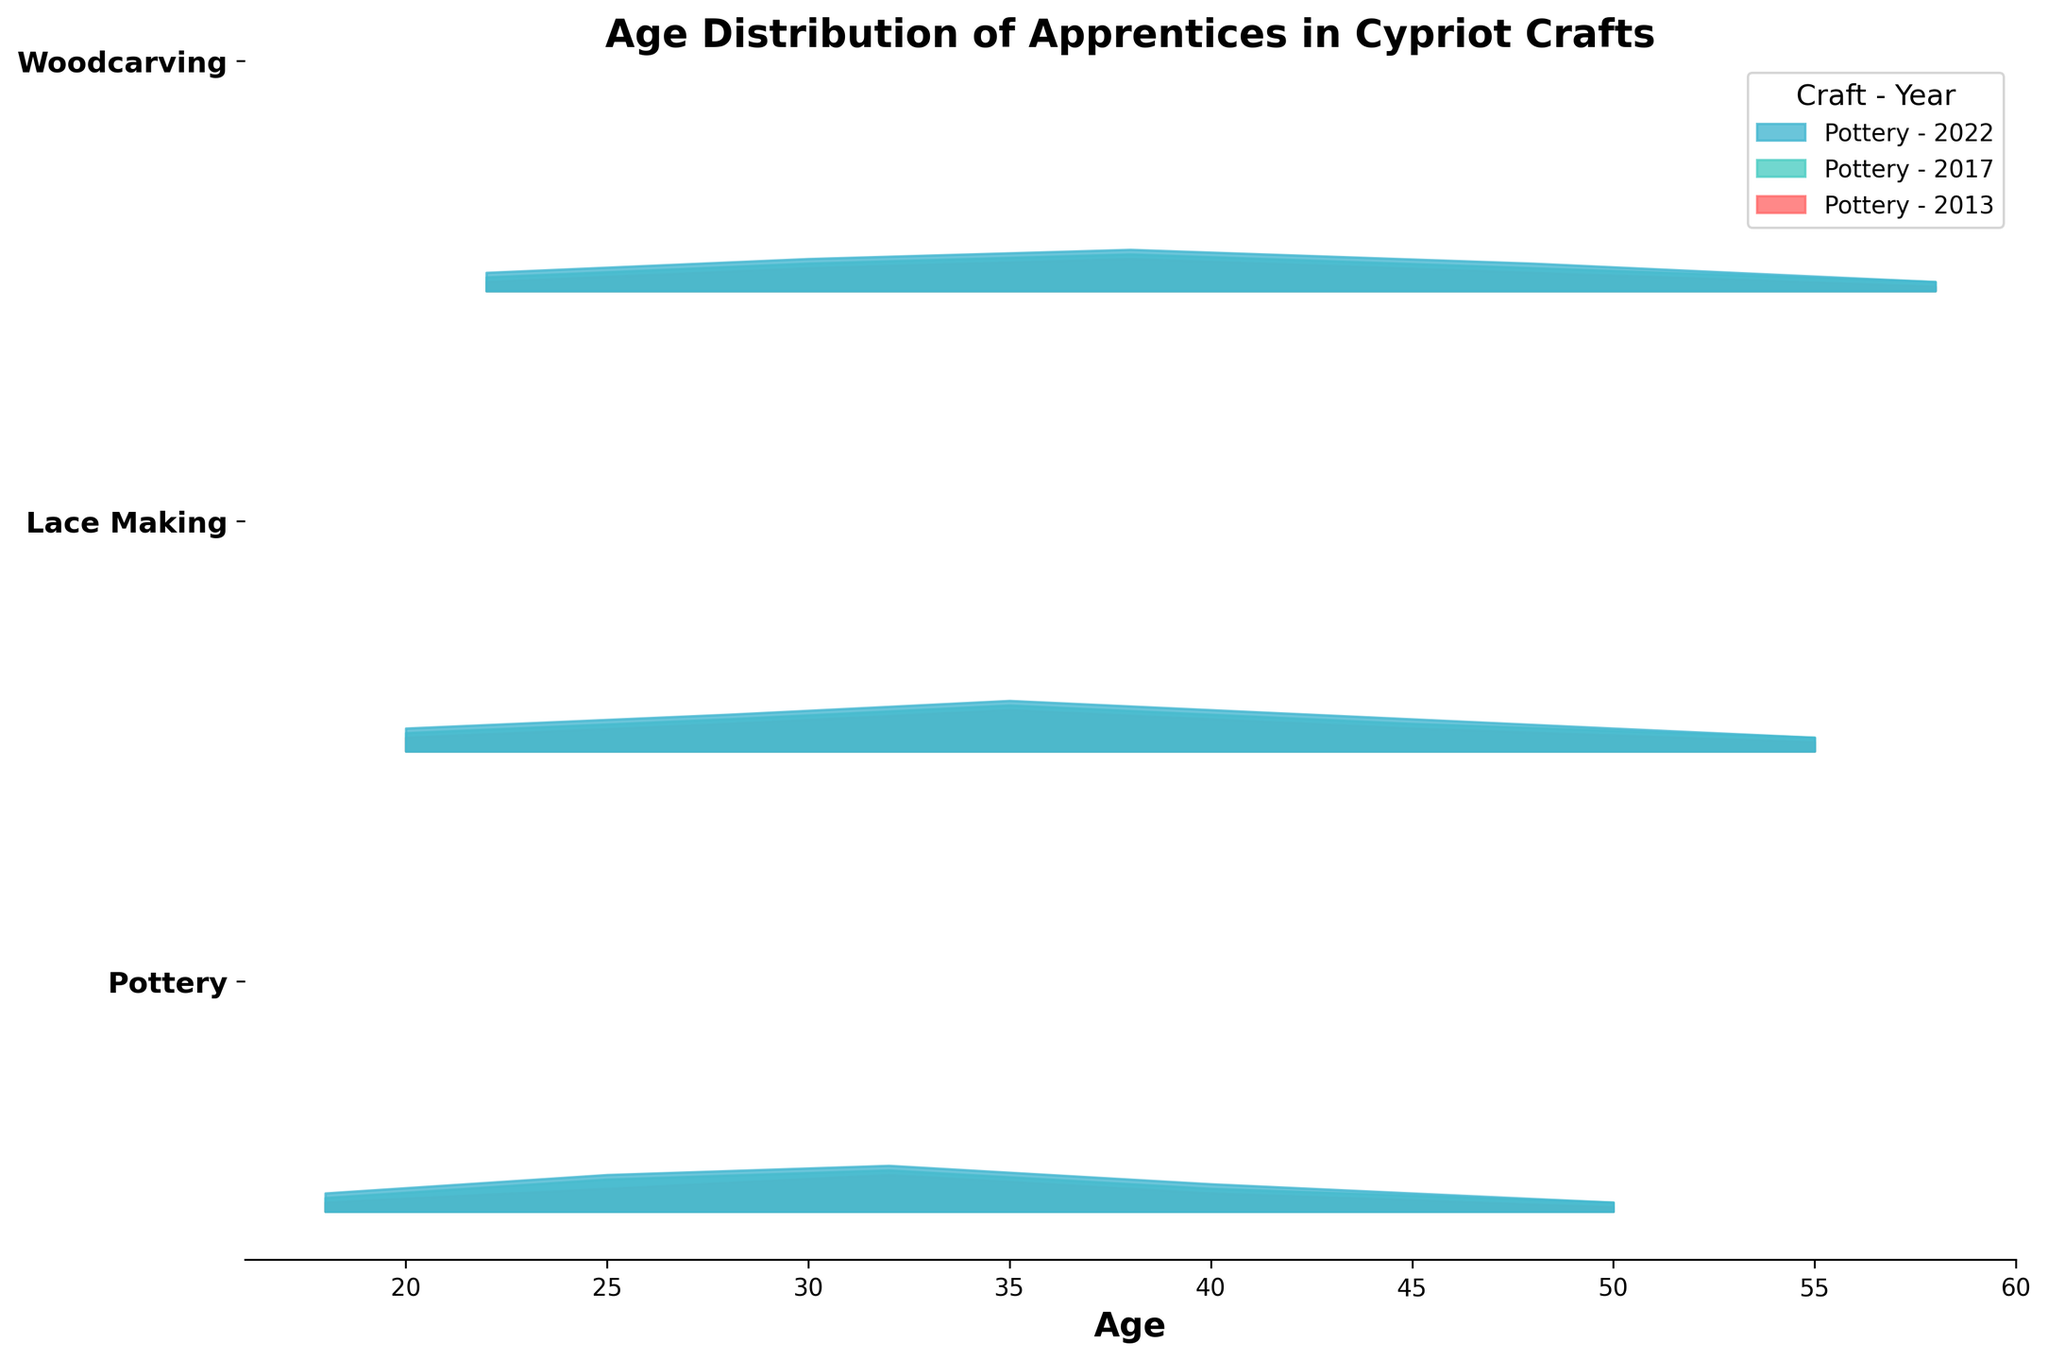What is the title of the Ridgeline plot? The title of a plot is usually found at the top. In this case, it reads "Age Distribution of Apprentices in Cypriot Crafts".
Answer: Age Distribution of Apprentices in Cypriot Crafts Which age group in Pottery in 2022 has the highest density of apprentices? By observing the peaks of the densities for the specific year and craft, the highest density for Pottery in 2022 corresponds to age 32.
Answer: Age 32 How does the age distribution of Lace Making apprentices change from 2013 to 2022? Over the years, observe the increase in density values for each age group line for Lace Making. There is a noticeable rise in density across all ages from 2013 to 2022. The highest densities shift slightly older, moving from ages 35 towards ages 35-45.
Answer: Densities increase, highest densities shift older Which craft had the most consistent age distribution over the years? A consistent age distribution would show similar density patterns across the years. Pottery shows a relatively consistent distribution, with all years having peaks at the same ages with minor changes in density values.
Answer: Pottery Is the density of apprentices in Woodcarving at age 38 higher in 2022 than in 2013? Compare the density values at age 38 for both years in the Woodcarving section. The density for 2022 (0.09) is higher than that of 2013 (0.07).
Answer: Yes Describe the color scheme used in the plot. The colors used in the plot transition from shades of red for earlier years to teal and blue for later years. Lighter shades represent earlier years, and darker shades correspond to later years.
Answer: Red to blue gradient Compare the density peaks for younger apprentices (under 25) across all crafts in 2022. By examining the density values for age groups under 25, Pottery has the highest peak (0.08), followed by Lace Making (0.05), and then Woodcarving (0.04).
Answer: Pottery > Lace Making > Woodcarving Which craft shows the widest age range of apprentices in the most recent data, 2022? The widest age range can be observed where densities are not zero for a wider range of ages. Woodcarving shows densities across ages 22 to 58, while Pottery and Lace Making show denser ranges but within 18 to 50 and 20 to 55 respectively.
Answer: Woodcarving What trends can be observed in the density of Lace Making apprentices from 2013 to 2022? There is a clear increasing trend in densities across all age groups from 2013 to 2022. Densities for all age groups improve, with noticeable density peaks shifting to slightly older age groups. This signifies growing interest over time.
Answer: Increasing trend, peaks shift older Which craft has the youngest average age of apprentices in 2017? The average age can be approximated by looking at the peak density regions. For 2017, Pottery has the youngest average age of apprentices centered around age 32. Other crafts have higher peaks at older ages.
Answer: Pottery 